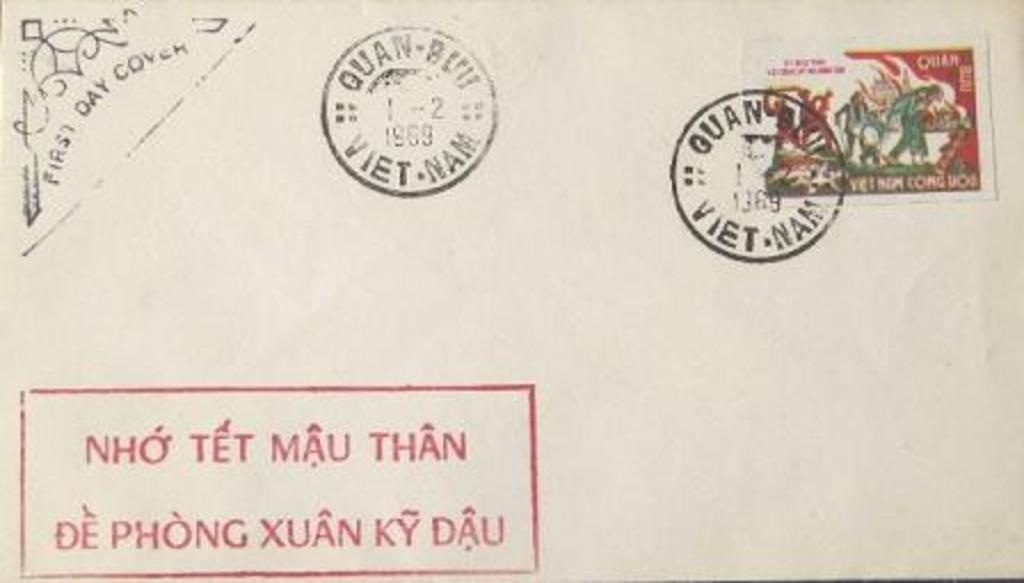Provide a one-sentence caption for the provided image. Vintage 1969 postage from Viet Nam with a post marked stamp on the stamp. 